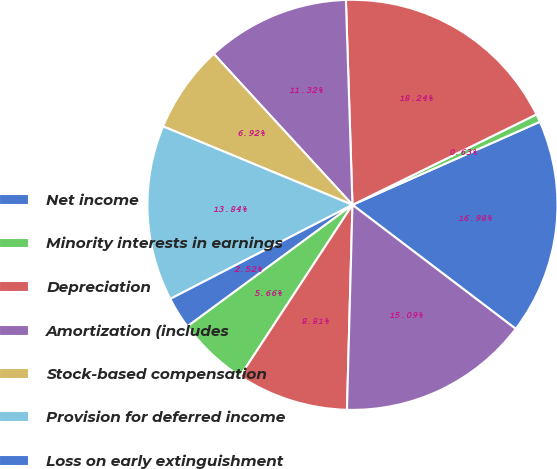Convert chart to OTSL. <chart><loc_0><loc_0><loc_500><loc_500><pie_chart><fcel>Net income<fcel>Minority interests in earnings<fcel>Depreciation<fcel>Amortization (includes<fcel>Stock-based compensation<fcel>Provision for deferred income<fcel>Loss on early extinguishment<fcel>(Gain) Loss on<fcel>Unrealized (Gain) Loss on<fcel>Accounts receivable<nl><fcel>16.98%<fcel>0.63%<fcel>18.24%<fcel>11.32%<fcel>6.92%<fcel>13.84%<fcel>2.52%<fcel>5.66%<fcel>8.81%<fcel>15.09%<nl></chart> 